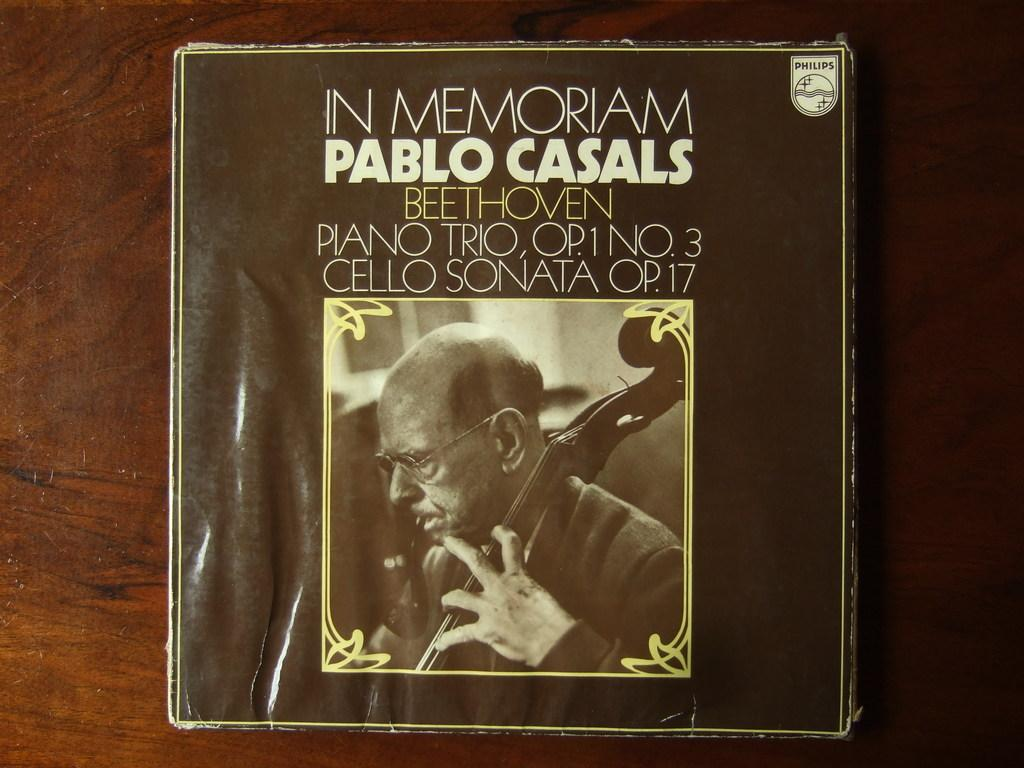<image>
Create a compact narrative representing the image presented. An In Memoriam by Pablo Casals CD collection. 